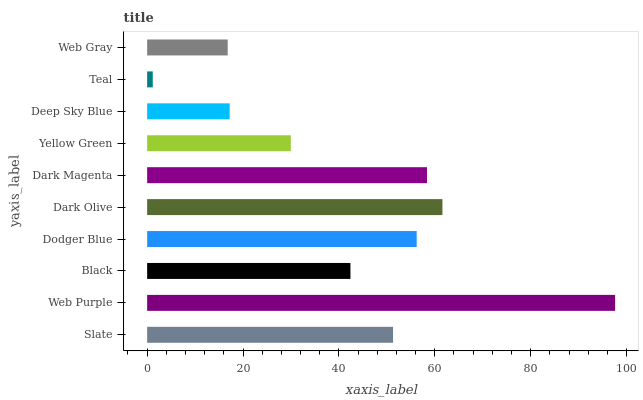Is Teal the minimum?
Answer yes or no. Yes. Is Web Purple the maximum?
Answer yes or no. Yes. Is Black the minimum?
Answer yes or no. No. Is Black the maximum?
Answer yes or no. No. Is Web Purple greater than Black?
Answer yes or no. Yes. Is Black less than Web Purple?
Answer yes or no. Yes. Is Black greater than Web Purple?
Answer yes or no. No. Is Web Purple less than Black?
Answer yes or no. No. Is Slate the high median?
Answer yes or no. Yes. Is Black the low median?
Answer yes or no. Yes. Is Yellow Green the high median?
Answer yes or no. No. Is Dark Olive the low median?
Answer yes or no. No. 